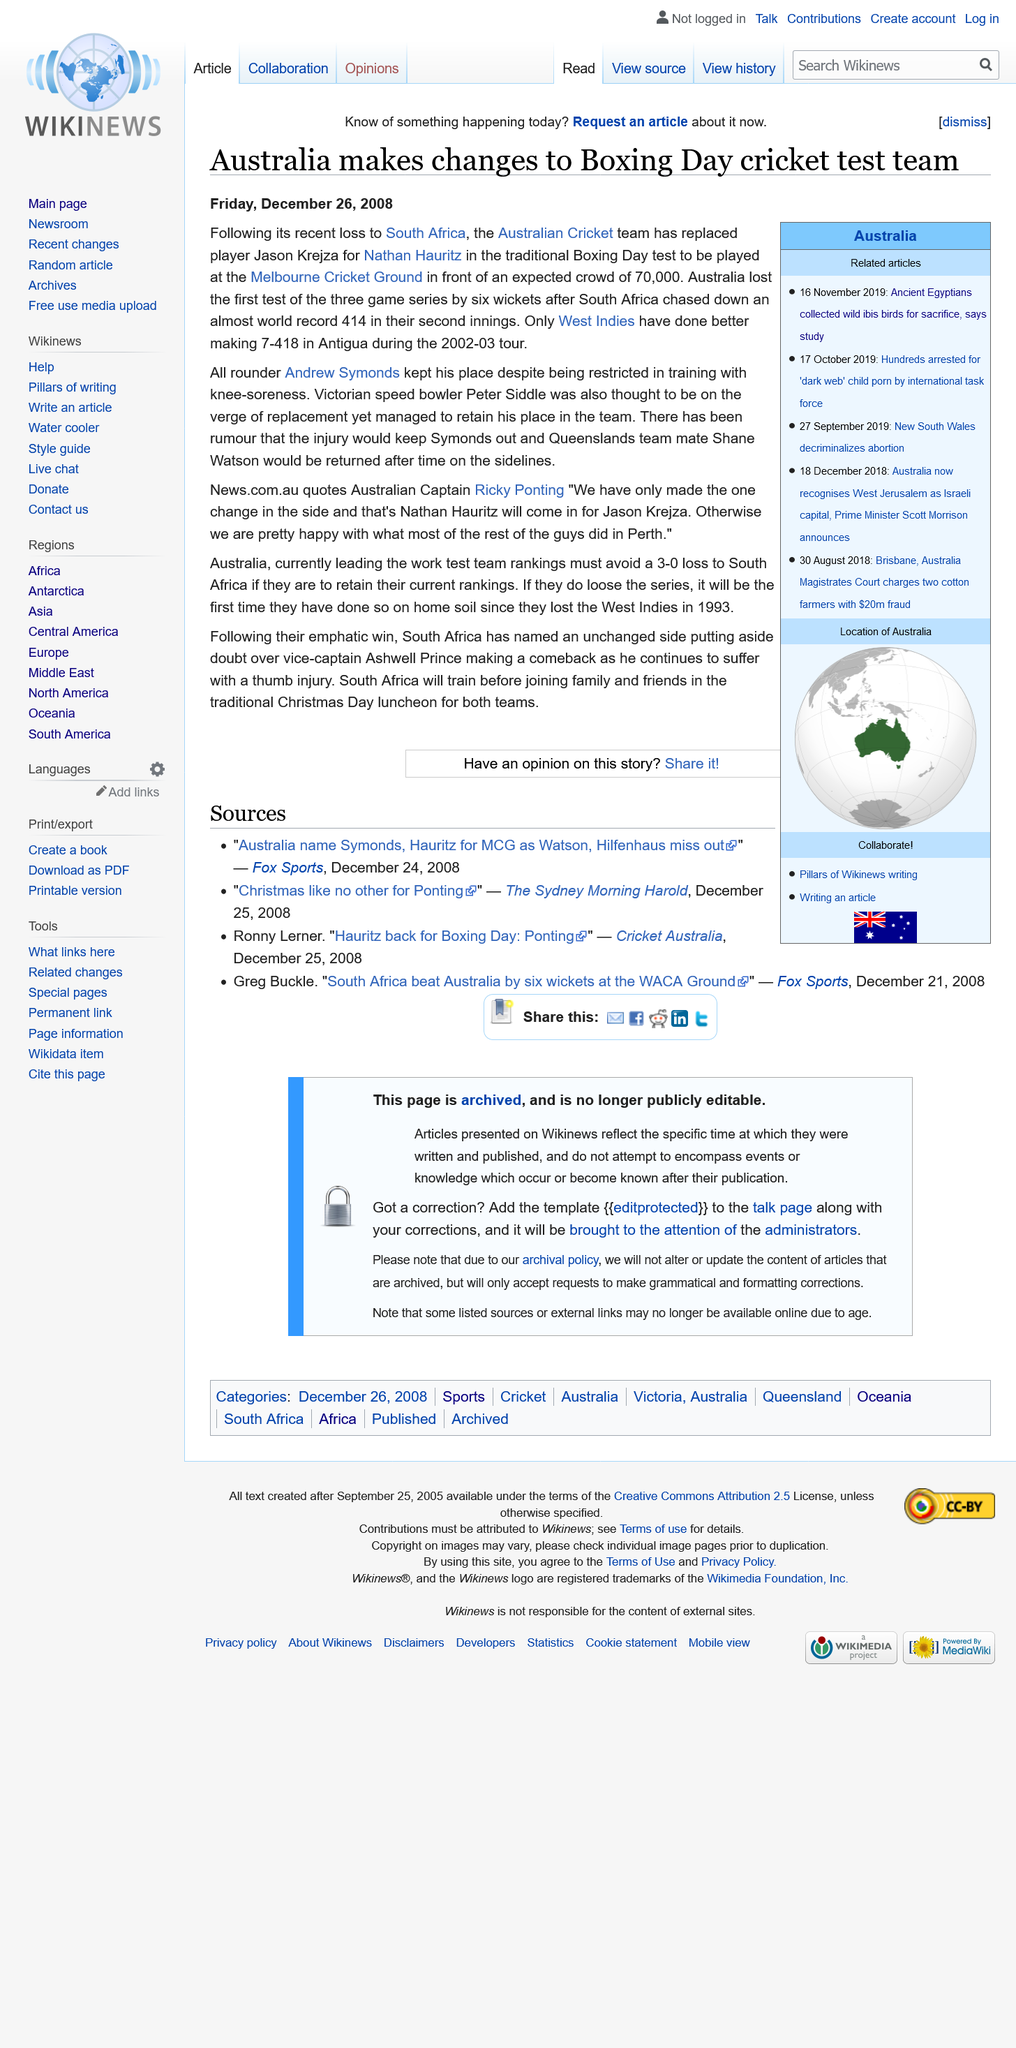Indicate a few pertinent items in this graphic. On Friday, December 26, 2008, the article regarding Australia's changes to their Boxing Day cricket test team was released. Peter Siddle, a renowned Victorian speed bowler, is the one and only Victorian speed bowler! The Boxing Day Test is expected to draw a crowd of 70,000 enthusiastic spectators. 